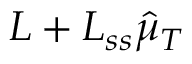Convert formula to latex. <formula><loc_0><loc_0><loc_500><loc_500>L + L _ { s s } \hat { \mu } _ { T }</formula> 